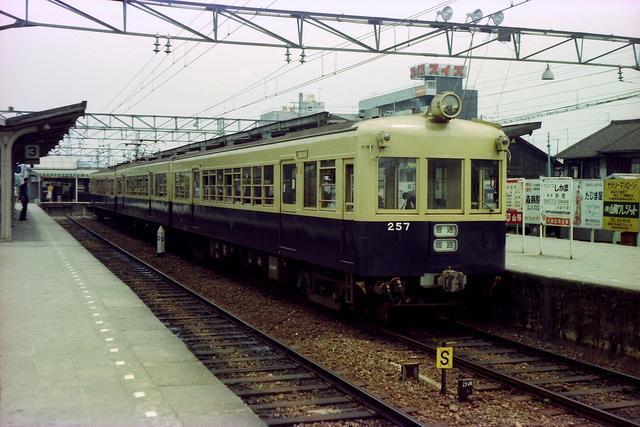How many people are on the platform?
Give a very brief answer. 1. 